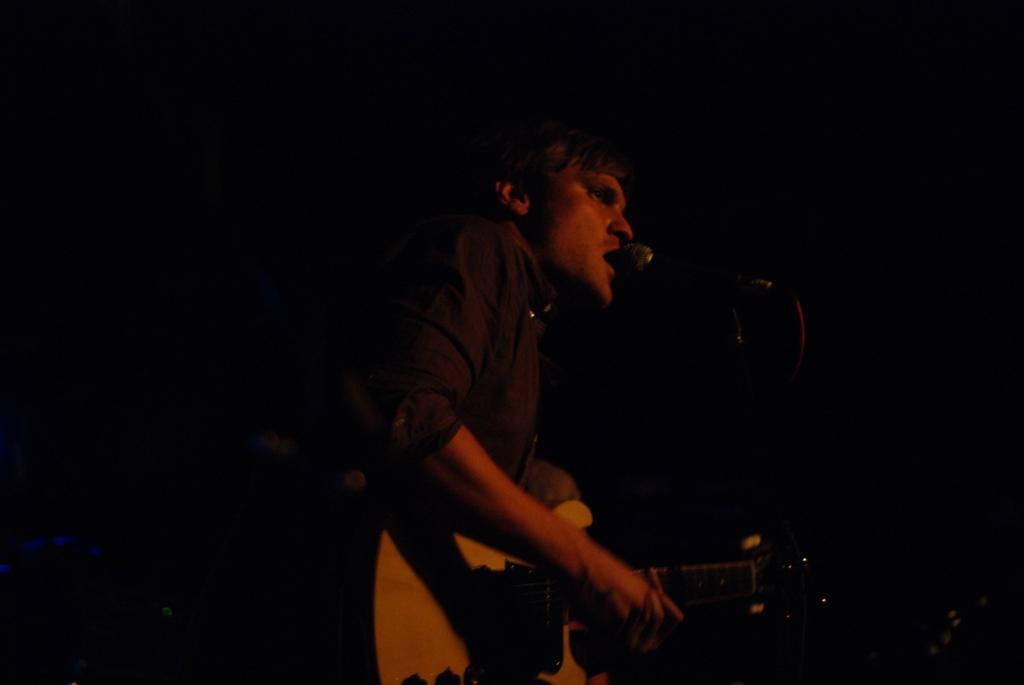What is the person in the image doing? The person is standing, holding a guitar, and singing. What object is the person using to amplify their voice? There is a microphone with a stand in the image. What type of cave can be seen in the background of the image? There is no cave present in the image; it features a person holding a guitar and singing with a microphone and stand. What kind of bushes are growing near the person in the image? There are no bushes visible in the image; it only shows a person holding a guitar and singing with a microphone and stand. 